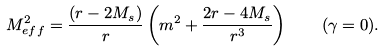<formula> <loc_0><loc_0><loc_500><loc_500>M _ { e f f } ^ { 2 } = \frac { ( r - 2 M _ { s } ) } { r } \left ( m ^ { 2 } + \frac { 2 r - 4 M _ { s } } { r ^ { 3 } } \right ) \quad ( \gamma = 0 ) .</formula> 